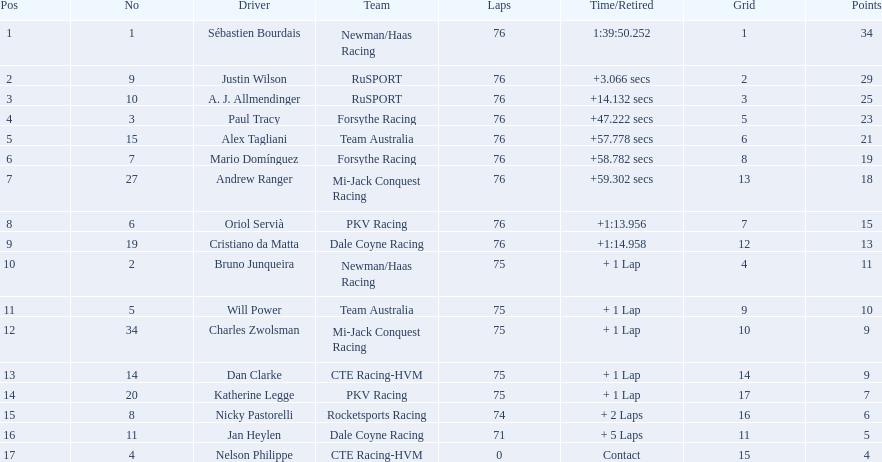What was the overall point tally for canada? 62. 